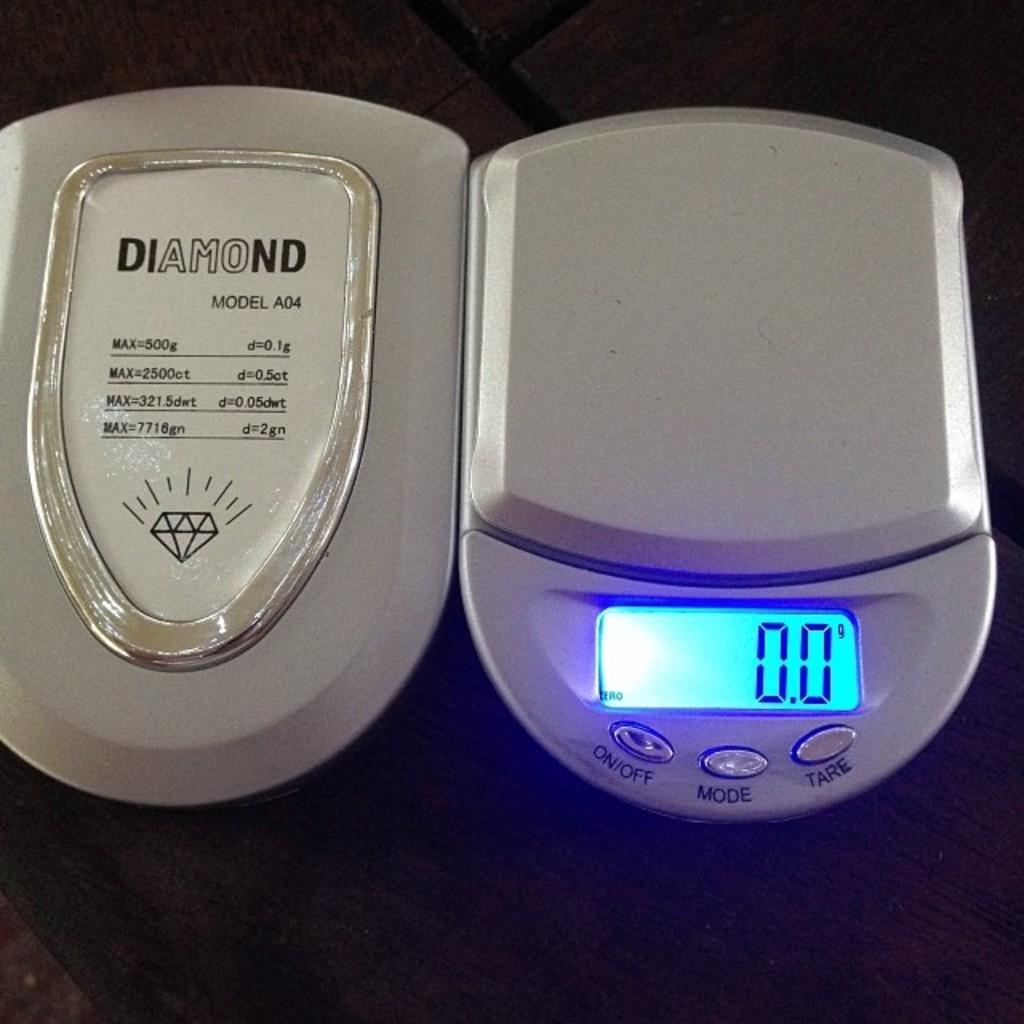<image>
Write a terse but informative summary of the picture. A small white and silver Diamond scale model A04 